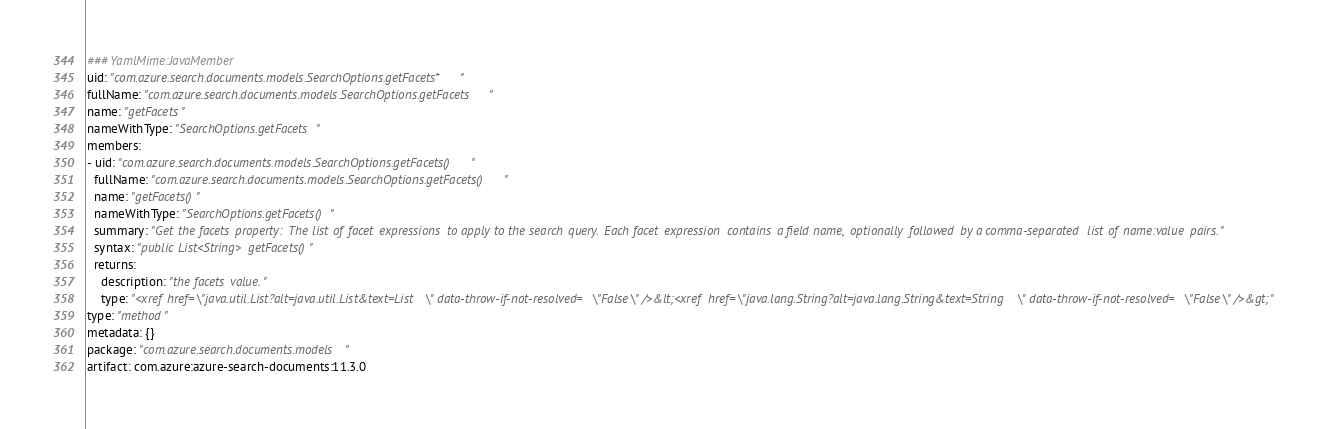Convert code to text. <code><loc_0><loc_0><loc_500><loc_500><_YAML_>### YamlMime:JavaMember
uid: "com.azure.search.documents.models.SearchOptions.getFacets*"
fullName: "com.azure.search.documents.models.SearchOptions.getFacets"
name: "getFacets"
nameWithType: "SearchOptions.getFacets"
members:
- uid: "com.azure.search.documents.models.SearchOptions.getFacets()"
  fullName: "com.azure.search.documents.models.SearchOptions.getFacets()"
  name: "getFacets()"
  nameWithType: "SearchOptions.getFacets()"
  summary: "Get the facets property: The list of facet expressions to apply to the search query. Each facet expression contains a field name, optionally followed by a comma-separated list of name:value pairs."
  syntax: "public List<String> getFacets()"
  returns:
    description: "the facets value."
    type: "<xref href=\"java.util.List?alt=java.util.List&text=List\" data-throw-if-not-resolved=\"False\" />&lt;<xref href=\"java.lang.String?alt=java.lang.String&text=String\" data-throw-if-not-resolved=\"False\" />&gt;"
type: "method"
metadata: {}
package: "com.azure.search.documents.models"
artifact: com.azure:azure-search-documents:11.3.0
</code> 